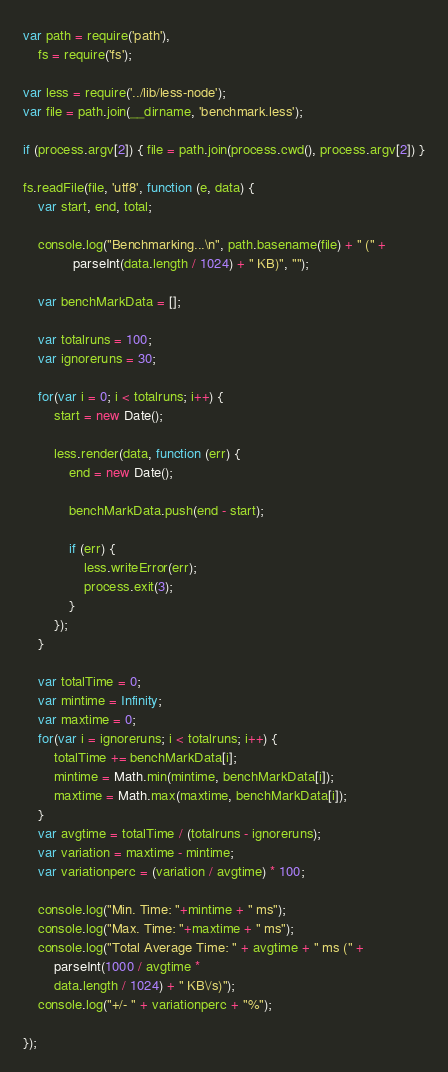Convert code to text. <code><loc_0><loc_0><loc_500><loc_500><_JavaScript_>var path = require('path'),
    fs = require('fs');

var less = require('../lib/less-node');
var file = path.join(__dirname, 'benchmark.less');

if (process.argv[2]) { file = path.join(process.cwd(), process.argv[2]) }

fs.readFile(file, 'utf8', function (e, data) {
    var start, end, total;

    console.log("Benchmarking...\n", path.basename(file) + " (" +
             parseInt(data.length / 1024) + " KB)", "");

    var benchMarkData = [];

    var totalruns = 100;
    var ignoreruns = 30;

    for(var i = 0; i < totalruns; i++) {
        start = new Date();

        less.render(data, function (err) {
            end = new Date();

            benchMarkData.push(end - start);

            if (err) {
                less.writeError(err);
                process.exit(3);
            }
        });
    }

    var totalTime = 0;
    var mintime = Infinity;
    var maxtime = 0;
    for(var i = ignoreruns; i < totalruns; i++) {
        totalTime += benchMarkData[i];
        mintime = Math.min(mintime, benchMarkData[i]);
        maxtime = Math.max(maxtime, benchMarkData[i]);
    }
    var avgtime = totalTime / (totalruns - ignoreruns);
    var variation = maxtime - mintime;
    var variationperc = (variation / avgtime) * 100;

    console.log("Min. Time: "+mintime + " ms");
    console.log("Max. Time: "+maxtime + " ms");
    console.log("Total Average Time: " + avgtime + " ms (" +
        parseInt(1000 / avgtime *
        data.length / 1024) + " KB\/s)");
    console.log("+/- " + variationperc + "%");

});

</code> 